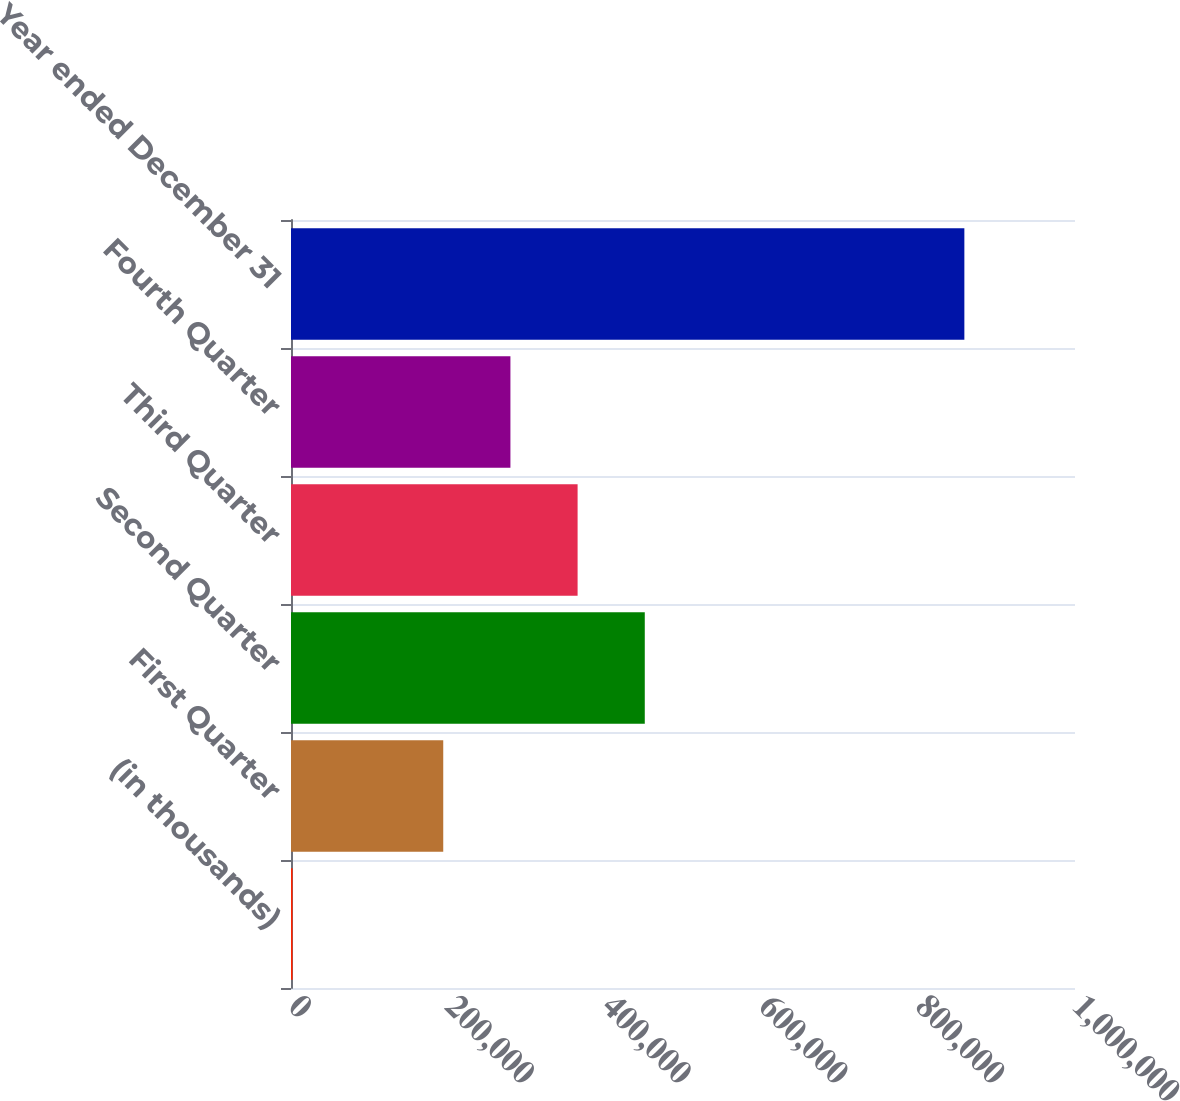Convert chart to OTSL. <chart><loc_0><loc_0><loc_500><loc_500><bar_chart><fcel>(in thousands)<fcel>First Quarter<fcel>Second Quarter<fcel>Third Quarter<fcel>Fourth Quarter<fcel>Year ended December 31<nl><fcel>2006<fcel>194187<fcel>451249<fcel>365561<fcel>279874<fcel>858878<nl></chart> 